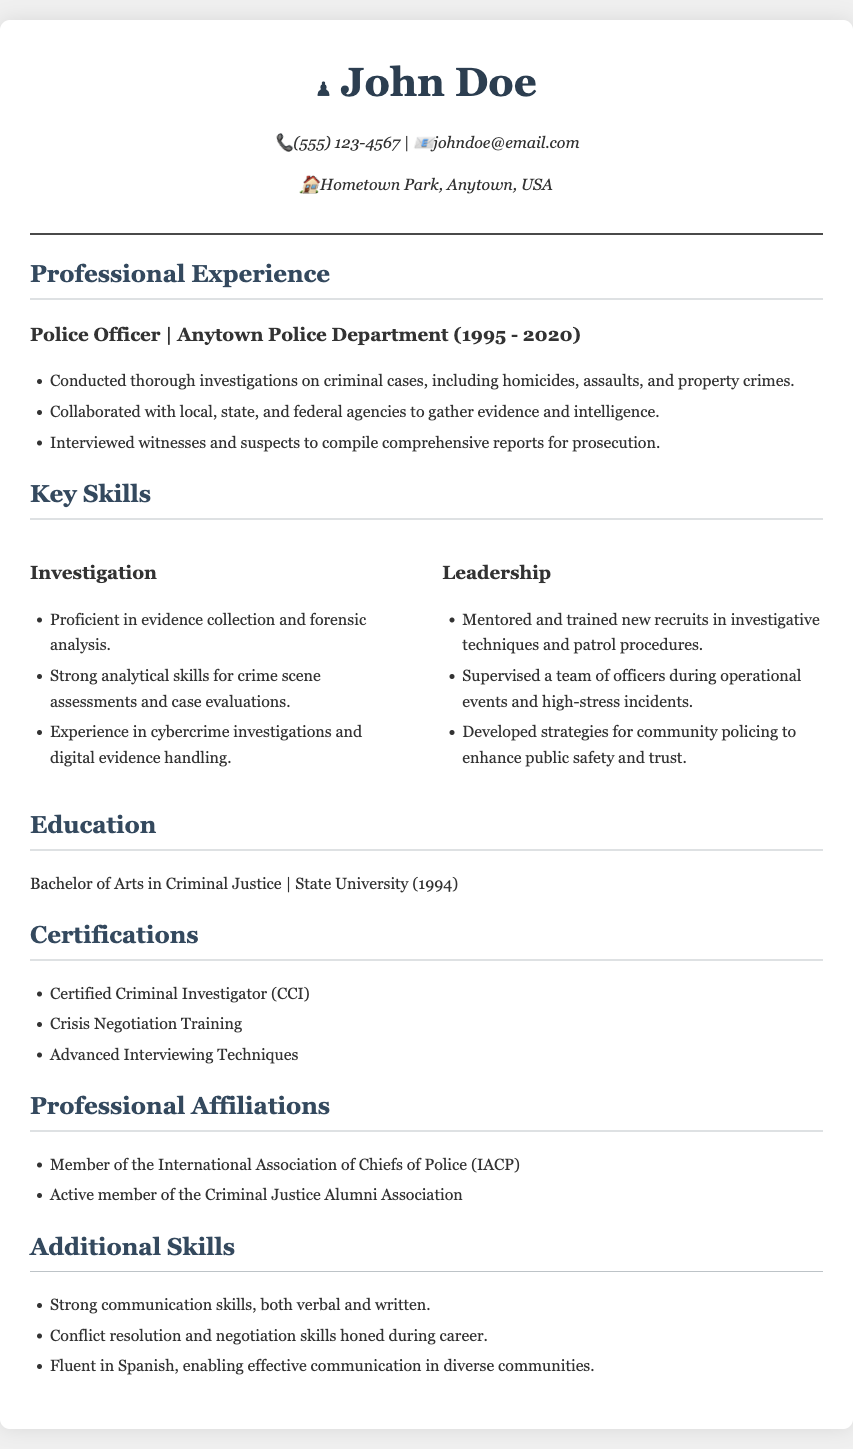What was John Doe's position at the Anytown Police Department? The position held is stated clearly in the document as "Police Officer."
Answer: Police Officer What years did John Doe work at the Anytown Police Department? The document specifies the time frame of employment as 1995 to 2020.
Answer: 1995 - 2020 What key skill is associated with the collection and analysis of evidence? The document lists "Proficient in evidence collection and forensic analysis" under the Investigation skills section.
Answer: Investigation Who did John Doe supervise during operational events? According to the Leadership section, he supervised a "team of officers."
Answer: team of officers What certification does John Doe hold that relates to investigation? The document lists "Certified Criminal Investigator (CCI)" as one of the certifications.
Answer: Certified Criminal Investigator (CCI) How many years of experience does John Doe have in the police department? The years worked are from 1995 to 2020, totaling 25 years of experience.
Answer: 25 years In what way is John Doe's leadership experience described in terms of community involvement? The document states he "developed strategies for community policing to enhance public safety and trust."
Answer: community policing What is one of the additional skills mentioned in the document? The document lists "Strong communication skills, both verbal and written" under Additional Skills.
Answer: Strong communication skills 